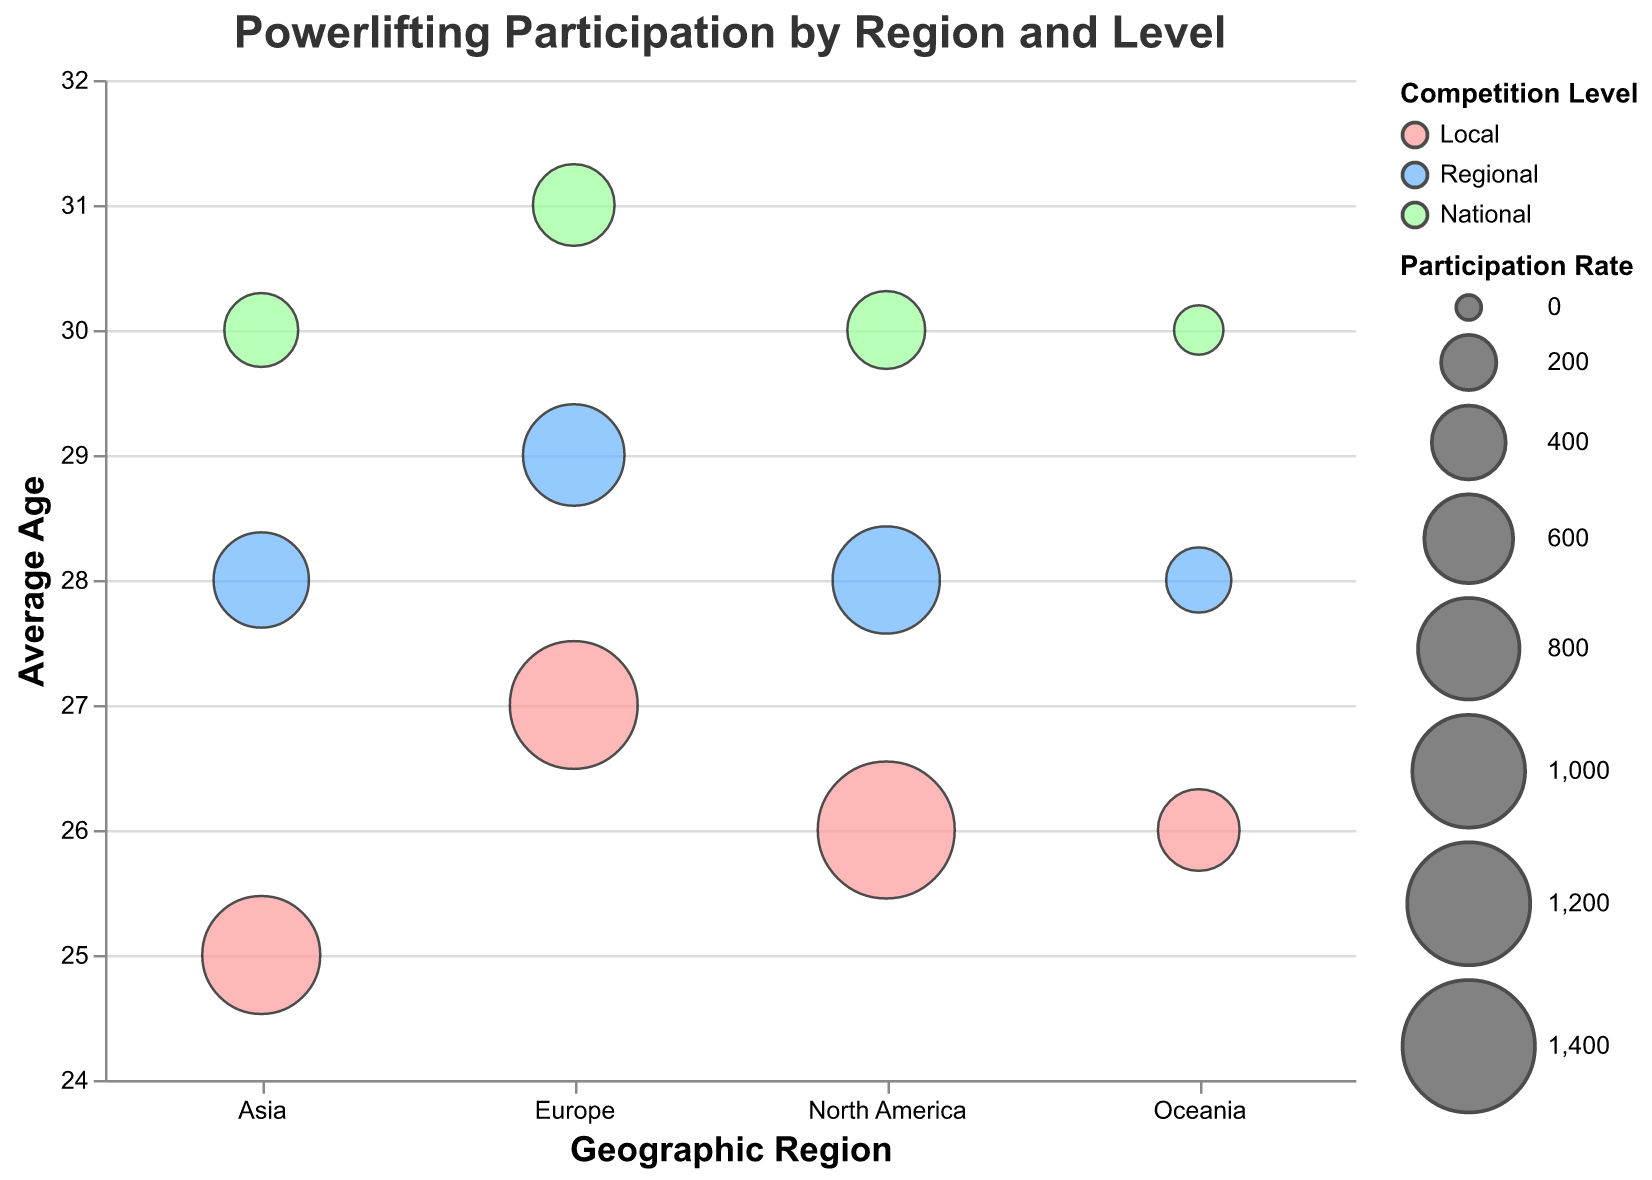What is the title of the chart? The title is prominently displayed at the top of the chart.
Answer: "Powerlifting Participation by Region and Level" How many Geographic Regions are compared in the chart? The x-axis shows the distinct categories for Geographic Regions, which are North America, Europe, Asia, and Oceania.
Answer: 4 Which competition level has the highest participation rate in North America? By looking at the size of the bubbles within North America, the largest bubble corresponds to the Local competition level.
Answer: Local What is the average age for participants in National level competitions in Europe? Hovering or examining the tooltip for the National level bubble in the Europe region reveals the average age.
Answer: 31 Which Geographic Region has the smallest bubble size for Local competitions? By comparing the size of the bubbles corresponding to the Local competition level across all regions, Oceania has the smallest bubble.
Answer: Oceania How does the average age for Local competitions compare between Asia and Oceania? Examine the y-axis position of the Local competition bubbles for Asia and Oceania; Asia is at 25 and Oceania is at 26.
Answer: Asia has a younger average age by 1 year What is the total Participation Rate for National competitions across all Geographic Regions? Sum the Participation Rates for the National level in each region: 450 (North America) + 500 (Europe) + 400 (Asia) + 150 (Oceania) = 1500.
Answer: 1500 Which region has the most consistent average age across competition levels? By comparing the spread of bubbles along the y-axis for each region, North America and Oceania exhibit less variation in average age (around 26 to 30).
Answer: Impressionistic: North America or Oceania Which region has the highest Participation Rate for Regional competitions? Compare the size of the bubbles corresponding to the Regional competition level; North America has the largest bubble for Regional competitions.
Answer: North America Which competition level has the oldest average age across all regions? Examining the y-axis positions of all bubbles reveals that National level competitions generally have the highest average ages, with bubbles close to 30-31.
Answer: National 